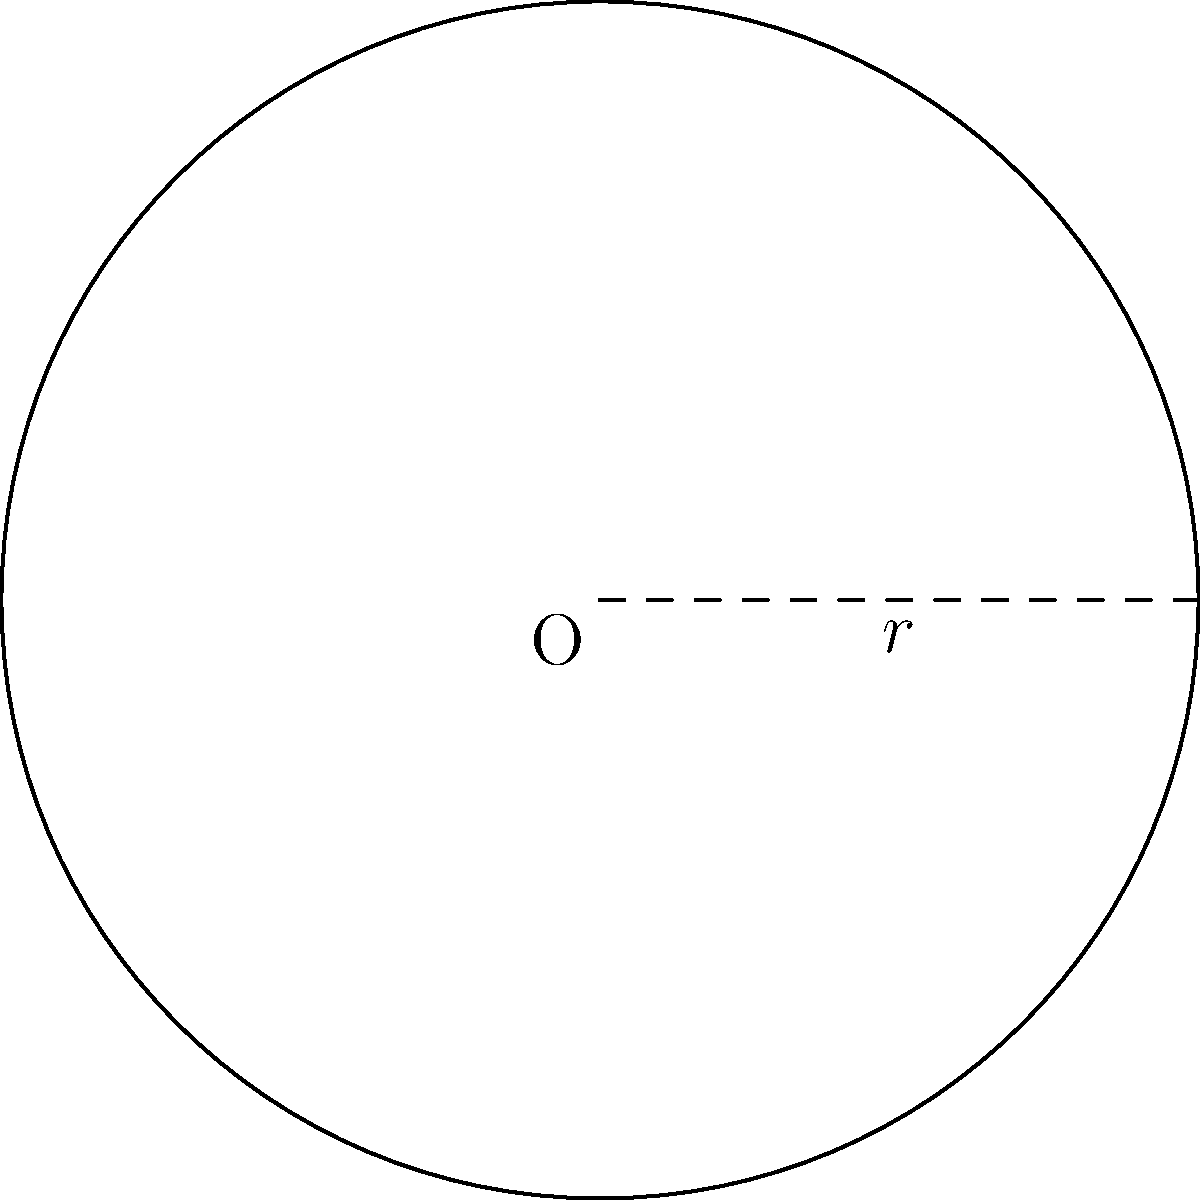As a sports journalist covering the construction of a new athletics facility in Tehran, you need to report on the dimensions of a circular running track. If the radius of the track is 100 meters, what is the total area of the track's surface in square meters? Round your answer to the nearest whole number. To find the area of a circular running track, we need to use the formula for the area of a circle:

$$A = \pi r^2$$

Where:
$A$ is the area
$\pi$ (pi) is approximately 3.14159
$r$ is the radius of the circle

Given:
$r = 100$ meters

Step 1: Substitute the radius into the formula
$$A = \pi (100)^2$$

Step 2: Calculate the square of the radius
$$A = \pi (10,000)$$

Step 3: Multiply by π
$$A = 31,415.9$$

Step 4: Round to the nearest whole number
$$A ≈ 31,416$$

Therefore, the total area of the circular running track is approximately 31,416 square meters.
Answer: 31,416 square meters 